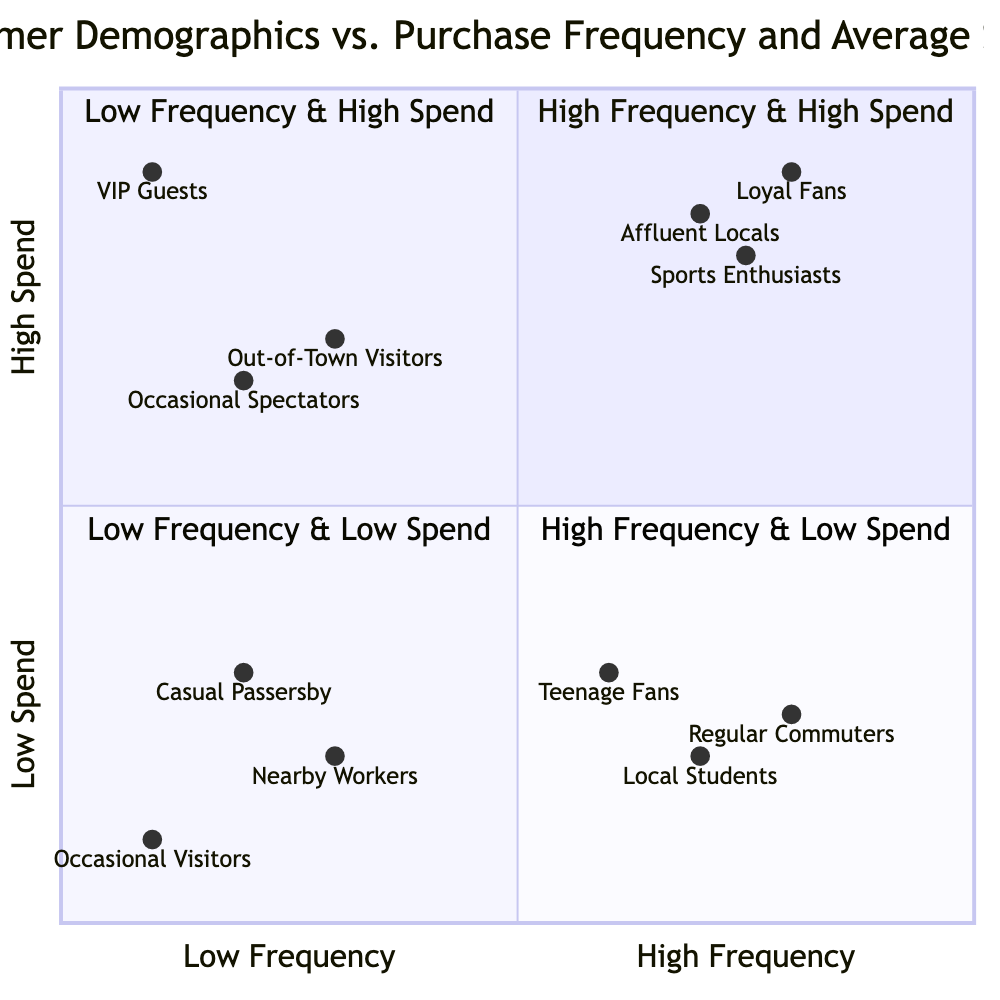What customer segment is in the High Frequency & High Spend quadrant? The High Frequency & High Spend quadrant contains several customer segments, including "Loyal Fans," "Affluent Locals," and "Sports Enthusiasts."
Answer: Loyal Fans, Affluent Locals, Sports Enthusiasts How many customer segments are in the Low Frequency & High Spend quadrant? The Low Frequency & High Spend quadrant includes three customer segments: "Out-of-Town Visitors," "Occasional Spectators," and "VIP Guests." This totals three segments.
Answer: 3 Which type of customers are in the High Frequency & Low Spend quadrant? The High Frequency & Low Spend quadrant contains customer segments such as "Teenage Fans," "Local Students," and "Regular Commuters."
Answer: Teenage Fans, Local Students, Regular Commuters What is the average spend of the customer segment labeled as 'VIP Guests'? The diagram indicates that 'VIP Guests' fall into the Low Frequency & High Spend quadrant, where the average spend is on the higher side. Specifically, their spend is shown with a higher range compared to other segments, revealing they spend significantly but visit infrequently.
Answer: High Spend How does the purchase frequency of 'Loyal Fans' compare to that of 'Casual Passersby'? 'Loyal Fans' are located in the High Frequency & High Spend quadrant, indicating they visit frequently, while 'Casual Passersby' reside in the Low Frequency & Low Spend quadrant, showing they visit infrequently. Thus, 'Loyal Fans' have a higher purchase frequency than 'Casual Passersby'.
Answer: Higher Which quadrant contains 'Local Students'? 'Local Students' are located in the High Frequency & Low Spend quadrant. This segment indicates they visit frequently but spend less per visit on match days.
Answer: High Frequency & Low Spend What is the relationship between purchase frequency and average spend for 'Occasional Visitors'? 'Occasional Visitors' are in the Low Frequency & Low Spend quadrant, which indicates that they visit infrequently and spend less per visit. Therefore, the relationship shows low purchase frequency correlates with low average spend.
Answer: Low Frequency & Low Spend Which segment has the lowest purchase frequency in the diagram? Among the customer segments, 'Occasional Visitors' have the lowest purchase frequency since they belong to the Low Frequency & Low Spend quadrant, indicating infrequent visits.
Answer: Occasional Visitors 